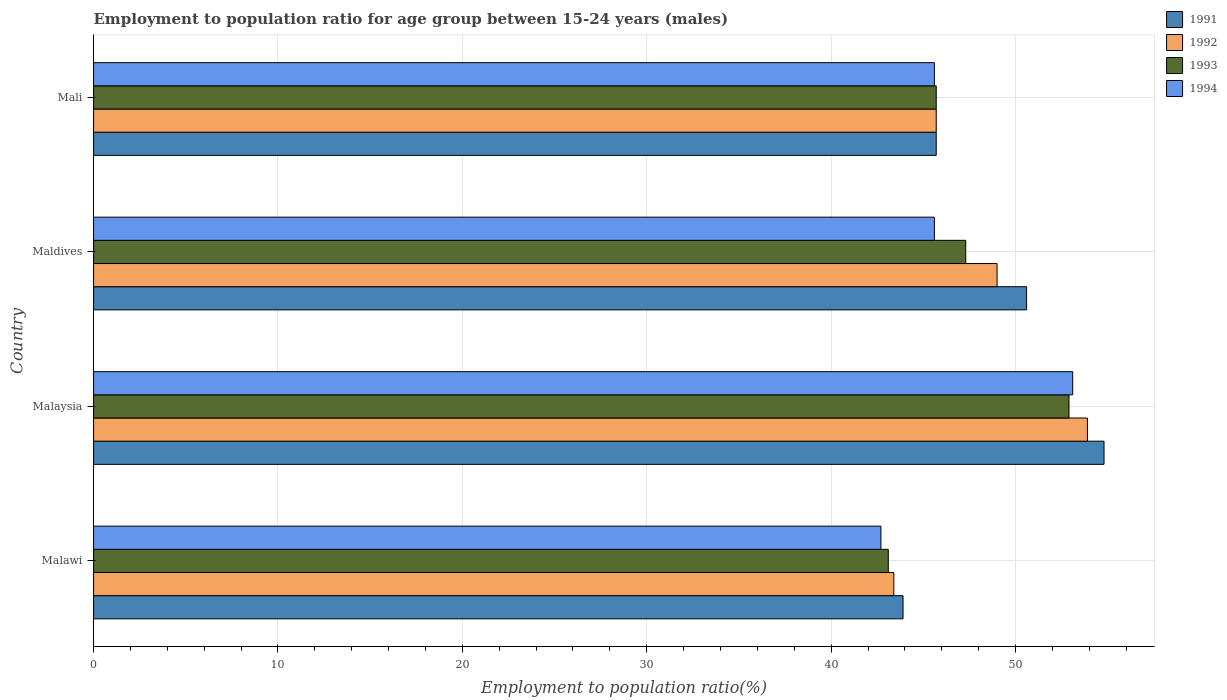How many groups of bars are there?
Give a very brief answer. 4. What is the label of the 1st group of bars from the top?
Your answer should be compact. Mali. In how many cases, is the number of bars for a given country not equal to the number of legend labels?
Provide a succinct answer. 0. What is the employment to population ratio in 1992 in Maldives?
Make the answer very short. 49. Across all countries, what is the maximum employment to population ratio in 1991?
Provide a short and direct response. 54.8. Across all countries, what is the minimum employment to population ratio in 1993?
Your answer should be very brief. 43.1. In which country was the employment to population ratio in 1991 maximum?
Your response must be concise. Malaysia. In which country was the employment to population ratio in 1992 minimum?
Provide a short and direct response. Malawi. What is the total employment to population ratio in 1992 in the graph?
Your response must be concise. 192. What is the difference between the employment to population ratio in 1994 in Malawi and that in Mali?
Keep it short and to the point. -2.9. What is the difference between the employment to population ratio in 1991 in Malawi and the employment to population ratio in 1993 in Mali?
Make the answer very short. -1.8. What is the average employment to population ratio in 1992 per country?
Offer a terse response. 48. What is the difference between the employment to population ratio in 1994 and employment to population ratio in 1992 in Maldives?
Provide a short and direct response. -3.4. In how many countries, is the employment to population ratio in 1992 greater than 14 %?
Your response must be concise. 4. What is the ratio of the employment to population ratio in 1991 in Malaysia to that in Maldives?
Your answer should be very brief. 1.08. Is the employment to population ratio in 1992 in Malawi less than that in Mali?
Make the answer very short. Yes. What is the difference between the highest and the second highest employment to population ratio in 1992?
Provide a succinct answer. 4.9. What is the difference between the highest and the lowest employment to population ratio in 1991?
Offer a very short reply. 10.9. Is the sum of the employment to population ratio in 1992 in Malaysia and Mali greater than the maximum employment to population ratio in 1994 across all countries?
Make the answer very short. Yes. What does the 3rd bar from the top in Mali represents?
Your answer should be very brief. 1992. What does the 2nd bar from the bottom in Malawi represents?
Provide a short and direct response. 1992. Are the values on the major ticks of X-axis written in scientific E-notation?
Ensure brevity in your answer.  No. Does the graph contain grids?
Your response must be concise. Yes. Where does the legend appear in the graph?
Provide a short and direct response. Top right. How many legend labels are there?
Your answer should be compact. 4. What is the title of the graph?
Offer a terse response. Employment to population ratio for age group between 15-24 years (males). Does "1975" appear as one of the legend labels in the graph?
Your answer should be compact. No. What is the label or title of the Y-axis?
Ensure brevity in your answer.  Country. What is the Employment to population ratio(%) in 1991 in Malawi?
Your response must be concise. 43.9. What is the Employment to population ratio(%) in 1992 in Malawi?
Offer a terse response. 43.4. What is the Employment to population ratio(%) of 1993 in Malawi?
Offer a terse response. 43.1. What is the Employment to population ratio(%) of 1994 in Malawi?
Ensure brevity in your answer.  42.7. What is the Employment to population ratio(%) in 1991 in Malaysia?
Ensure brevity in your answer.  54.8. What is the Employment to population ratio(%) in 1992 in Malaysia?
Keep it short and to the point. 53.9. What is the Employment to population ratio(%) of 1993 in Malaysia?
Provide a short and direct response. 52.9. What is the Employment to population ratio(%) of 1994 in Malaysia?
Give a very brief answer. 53.1. What is the Employment to population ratio(%) in 1991 in Maldives?
Your response must be concise. 50.6. What is the Employment to population ratio(%) in 1993 in Maldives?
Ensure brevity in your answer.  47.3. What is the Employment to population ratio(%) of 1994 in Maldives?
Offer a very short reply. 45.6. What is the Employment to population ratio(%) in 1991 in Mali?
Provide a succinct answer. 45.7. What is the Employment to population ratio(%) in 1992 in Mali?
Your response must be concise. 45.7. What is the Employment to population ratio(%) in 1993 in Mali?
Give a very brief answer. 45.7. What is the Employment to population ratio(%) of 1994 in Mali?
Your answer should be compact. 45.6. Across all countries, what is the maximum Employment to population ratio(%) in 1991?
Offer a terse response. 54.8. Across all countries, what is the maximum Employment to population ratio(%) of 1992?
Your answer should be very brief. 53.9. Across all countries, what is the maximum Employment to population ratio(%) in 1993?
Provide a short and direct response. 52.9. Across all countries, what is the maximum Employment to population ratio(%) in 1994?
Offer a very short reply. 53.1. Across all countries, what is the minimum Employment to population ratio(%) in 1991?
Ensure brevity in your answer.  43.9. Across all countries, what is the minimum Employment to population ratio(%) in 1992?
Give a very brief answer. 43.4. Across all countries, what is the minimum Employment to population ratio(%) in 1993?
Your answer should be compact. 43.1. Across all countries, what is the minimum Employment to population ratio(%) in 1994?
Provide a succinct answer. 42.7. What is the total Employment to population ratio(%) of 1991 in the graph?
Provide a short and direct response. 195. What is the total Employment to population ratio(%) of 1992 in the graph?
Offer a terse response. 192. What is the total Employment to population ratio(%) in 1993 in the graph?
Keep it short and to the point. 189. What is the total Employment to population ratio(%) in 1994 in the graph?
Offer a terse response. 187. What is the difference between the Employment to population ratio(%) of 1991 in Malawi and that in Malaysia?
Ensure brevity in your answer.  -10.9. What is the difference between the Employment to population ratio(%) of 1993 in Malawi and that in Malaysia?
Offer a very short reply. -9.8. What is the difference between the Employment to population ratio(%) in 1994 in Malawi and that in Malaysia?
Offer a very short reply. -10.4. What is the difference between the Employment to population ratio(%) of 1992 in Malawi and that in Maldives?
Provide a succinct answer. -5.6. What is the difference between the Employment to population ratio(%) in 1991 in Malawi and that in Mali?
Make the answer very short. -1.8. What is the difference between the Employment to population ratio(%) in 1993 in Malawi and that in Mali?
Offer a terse response. -2.6. What is the difference between the Employment to population ratio(%) in 1994 in Malawi and that in Mali?
Provide a short and direct response. -2.9. What is the difference between the Employment to population ratio(%) in 1991 in Malaysia and that in Maldives?
Ensure brevity in your answer.  4.2. What is the difference between the Employment to population ratio(%) of 1992 in Malaysia and that in Maldives?
Your answer should be very brief. 4.9. What is the difference between the Employment to population ratio(%) of 1994 in Malaysia and that in Maldives?
Offer a very short reply. 7.5. What is the difference between the Employment to population ratio(%) in 1992 in Malaysia and that in Mali?
Provide a short and direct response. 8.2. What is the difference between the Employment to population ratio(%) in 1994 in Malaysia and that in Mali?
Your response must be concise. 7.5. What is the difference between the Employment to population ratio(%) in 1994 in Maldives and that in Mali?
Provide a succinct answer. 0. What is the difference between the Employment to population ratio(%) of 1991 in Malawi and the Employment to population ratio(%) of 1992 in Malaysia?
Offer a very short reply. -10. What is the difference between the Employment to population ratio(%) in 1991 in Malawi and the Employment to population ratio(%) in 1993 in Malaysia?
Your answer should be compact. -9. What is the difference between the Employment to population ratio(%) in 1991 in Malawi and the Employment to population ratio(%) in 1994 in Malaysia?
Provide a short and direct response. -9.2. What is the difference between the Employment to population ratio(%) in 1992 in Malawi and the Employment to population ratio(%) in 1994 in Malaysia?
Provide a succinct answer. -9.7. What is the difference between the Employment to population ratio(%) of 1991 in Malawi and the Employment to population ratio(%) of 1993 in Maldives?
Provide a succinct answer. -3.4. What is the difference between the Employment to population ratio(%) in 1991 in Malawi and the Employment to population ratio(%) in 1993 in Mali?
Keep it short and to the point. -1.8. What is the difference between the Employment to population ratio(%) of 1991 in Malawi and the Employment to population ratio(%) of 1994 in Mali?
Keep it short and to the point. -1.7. What is the difference between the Employment to population ratio(%) of 1992 in Malawi and the Employment to population ratio(%) of 1993 in Mali?
Make the answer very short. -2.3. What is the difference between the Employment to population ratio(%) in 1993 in Malawi and the Employment to population ratio(%) in 1994 in Mali?
Offer a terse response. -2.5. What is the difference between the Employment to population ratio(%) in 1991 in Malaysia and the Employment to population ratio(%) in 1994 in Maldives?
Your answer should be very brief. 9.2. What is the difference between the Employment to population ratio(%) of 1992 in Malaysia and the Employment to population ratio(%) of 1993 in Maldives?
Your response must be concise. 6.6. What is the difference between the Employment to population ratio(%) of 1993 in Malaysia and the Employment to population ratio(%) of 1994 in Maldives?
Ensure brevity in your answer.  7.3. What is the difference between the Employment to population ratio(%) of 1991 in Malaysia and the Employment to population ratio(%) of 1992 in Mali?
Ensure brevity in your answer.  9.1. What is the difference between the Employment to population ratio(%) in 1992 in Malaysia and the Employment to population ratio(%) in 1993 in Mali?
Provide a short and direct response. 8.2. What is the difference between the Employment to population ratio(%) of 1992 in Malaysia and the Employment to population ratio(%) of 1994 in Mali?
Your answer should be compact. 8.3. What is the difference between the Employment to population ratio(%) in 1993 in Malaysia and the Employment to population ratio(%) in 1994 in Mali?
Your response must be concise. 7.3. What is the difference between the Employment to population ratio(%) of 1992 in Maldives and the Employment to population ratio(%) of 1993 in Mali?
Offer a very short reply. 3.3. What is the difference between the Employment to population ratio(%) of 1992 in Maldives and the Employment to population ratio(%) of 1994 in Mali?
Keep it short and to the point. 3.4. What is the difference between the Employment to population ratio(%) of 1993 in Maldives and the Employment to population ratio(%) of 1994 in Mali?
Keep it short and to the point. 1.7. What is the average Employment to population ratio(%) in 1991 per country?
Provide a short and direct response. 48.75. What is the average Employment to population ratio(%) of 1992 per country?
Provide a succinct answer. 48. What is the average Employment to population ratio(%) in 1993 per country?
Offer a very short reply. 47.25. What is the average Employment to population ratio(%) in 1994 per country?
Provide a short and direct response. 46.75. What is the difference between the Employment to population ratio(%) in 1991 and Employment to population ratio(%) in 1994 in Malawi?
Provide a short and direct response. 1.2. What is the difference between the Employment to population ratio(%) in 1992 and Employment to population ratio(%) in 1993 in Malawi?
Ensure brevity in your answer.  0.3. What is the difference between the Employment to population ratio(%) in 1992 and Employment to population ratio(%) in 1994 in Malawi?
Your answer should be compact. 0.7. What is the difference between the Employment to population ratio(%) of 1993 and Employment to population ratio(%) of 1994 in Malawi?
Your response must be concise. 0.4. What is the difference between the Employment to population ratio(%) of 1991 and Employment to population ratio(%) of 1992 in Malaysia?
Offer a very short reply. 0.9. What is the difference between the Employment to population ratio(%) of 1992 and Employment to population ratio(%) of 1994 in Malaysia?
Offer a terse response. 0.8. What is the difference between the Employment to population ratio(%) of 1991 and Employment to population ratio(%) of 1992 in Maldives?
Give a very brief answer. 1.6. What is the difference between the Employment to population ratio(%) in 1992 and Employment to population ratio(%) in 1993 in Maldives?
Keep it short and to the point. 1.7. What is the difference between the Employment to population ratio(%) of 1992 and Employment to population ratio(%) of 1994 in Maldives?
Make the answer very short. 3.4. What is the difference between the Employment to population ratio(%) in 1991 and Employment to population ratio(%) in 1992 in Mali?
Make the answer very short. 0. What is the difference between the Employment to population ratio(%) in 1991 and Employment to population ratio(%) in 1993 in Mali?
Provide a short and direct response. 0. What is the difference between the Employment to population ratio(%) of 1992 and Employment to population ratio(%) of 1993 in Mali?
Keep it short and to the point. 0. What is the difference between the Employment to population ratio(%) of 1992 and Employment to population ratio(%) of 1994 in Mali?
Your answer should be compact. 0.1. What is the difference between the Employment to population ratio(%) in 1993 and Employment to population ratio(%) in 1994 in Mali?
Your answer should be compact. 0.1. What is the ratio of the Employment to population ratio(%) in 1991 in Malawi to that in Malaysia?
Offer a very short reply. 0.8. What is the ratio of the Employment to population ratio(%) of 1992 in Malawi to that in Malaysia?
Make the answer very short. 0.81. What is the ratio of the Employment to population ratio(%) in 1993 in Malawi to that in Malaysia?
Ensure brevity in your answer.  0.81. What is the ratio of the Employment to population ratio(%) in 1994 in Malawi to that in Malaysia?
Your answer should be compact. 0.8. What is the ratio of the Employment to population ratio(%) of 1991 in Malawi to that in Maldives?
Provide a short and direct response. 0.87. What is the ratio of the Employment to population ratio(%) in 1992 in Malawi to that in Maldives?
Your answer should be very brief. 0.89. What is the ratio of the Employment to population ratio(%) in 1993 in Malawi to that in Maldives?
Provide a short and direct response. 0.91. What is the ratio of the Employment to population ratio(%) of 1994 in Malawi to that in Maldives?
Your response must be concise. 0.94. What is the ratio of the Employment to population ratio(%) in 1991 in Malawi to that in Mali?
Offer a terse response. 0.96. What is the ratio of the Employment to population ratio(%) of 1992 in Malawi to that in Mali?
Your answer should be compact. 0.95. What is the ratio of the Employment to population ratio(%) in 1993 in Malawi to that in Mali?
Keep it short and to the point. 0.94. What is the ratio of the Employment to population ratio(%) in 1994 in Malawi to that in Mali?
Your answer should be very brief. 0.94. What is the ratio of the Employment to population ratio(%) of 1991 in Malaysia to that in Maldives?
Offer a very short reply. 1.08. What is the ratio of the Employment to population ratio(%) in 1992 in Malaysia to that in Maldives?
Ensure brevity in your answer.  1.1. What is the ratio of the Employment to population ratio(%) in 1993 in Malaysia to that in Maldives?
Make the answer very short. 1.12. What is the ratio of the Employment to population ratio(%) in 1994 in Malaysia to that in Maldives?
Provide a short and direct response. 1.16. What is the ratio of the Employment to population ratio(%) in 1991 in Malaysia to that in Mali?
Give a very brief answer. 1.2. What is the ratio of the Employment to population ratio(%) in 1992 in Malaysia to that in Mali?
Provide a succinct answer. 1.18. What is the ratio of the Employment to population ratio(%) in 1993 in Malaysia to that in Mali?
Provide a succinct answer. 1.16. What is the ratio of the Employment to population ratio(%) of 1994 in Malaysia to that in Mali?
Ensure brevity in your answer.  1.16. What is the ratio of the Employment to population ratio(%) in 1991 in Maldives to that in Mali?
Offer a terse response. 1.11. What is the ratio of the Employment to population ratio(%) in 1992 in Maldives to that in Mali?
Offer a very short reply. 1.07. What is the ratio of the Employment to population ratio(%) in 1993 in Maldives to that in Mali?
Your answer should be compact. 1.03. What is the ratio of the Employment to population ratio(%) in 1994 in Maldives to that in Mali?
Ensure brevity in your answer.  1. What is the difference between the highest and the second highest Employment to population ratio(%) of 1991?
Make the answer very short. 4.2. What is the difference between the highest and the second highest Employment to population ratio(%) of 1992?
Offer a very short reply. 4.9. What is the difference between the highest and the second highest Employment to population ratio(%) of 1993?
Give a very brief answer. 5.6. What is the difference between the highest and the second highest Employment to population ratio(%) of 1994?
Your answer should be compact. 7.5. What is the difference between the highest and the lowest Employment to population ratio(%) in 1991?
Your answer should be very brief. 10.9. What is the difference between the highest and the lowest Employment to population ratio(%) of 1992?
Your answer should be compact. 10.5. 